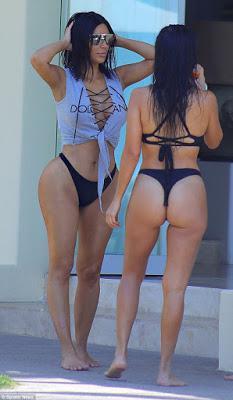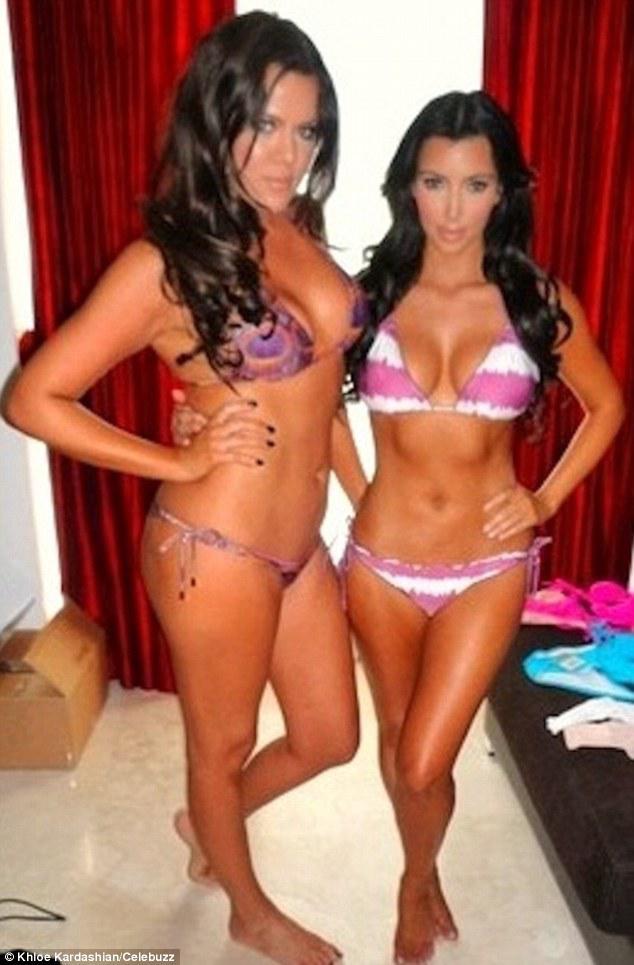The first image is the image on the left, the second image is the image on the right. For the images shown, is this caption "A model's bare foot appears in at least one of the images." true? Answer yes or no. Yes. 